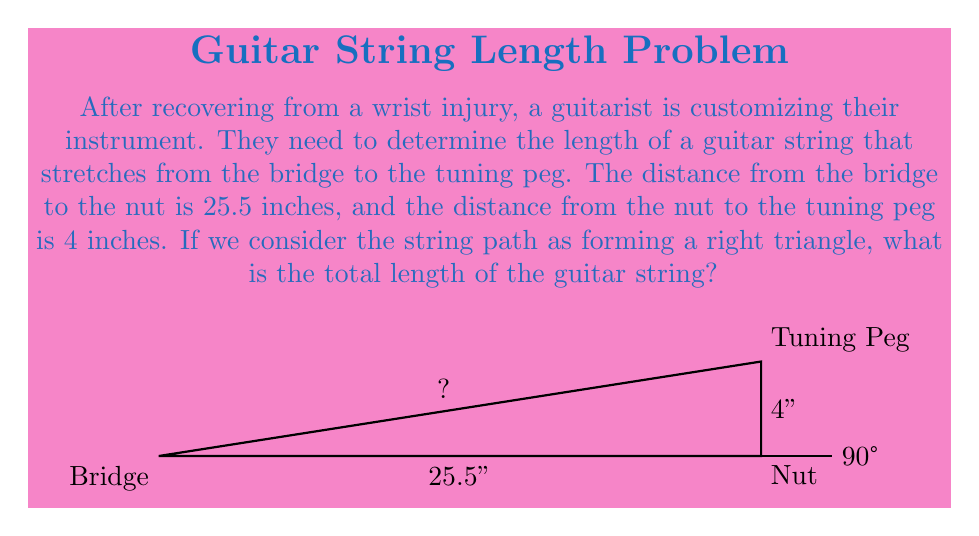Teach me how to tackle this problem. To solve this problem, we can use the Pythagorean theorem, which states that in a right triangle, the square of the length of the hypotenuse is equal to the sum of the squares of the other two sides.

Let's break it down step-by-step:

1) Let's denote the length of the string (hypotenuse) as $c$.

2) We know:
   - The distance from bridge to nut (base) is 25.5 inches
   - The distance from nut to tuning peg (height) is 4 inches

3) Using the Pythagorean theorem:

   $$c^2 = 25.5^2 + 4^2$$

4) Let's calculate the right side:
   $$c^2 = 650.25 + 16 = 666.25$$

5) To find $c$, we need to take the square root of both sides:
   $$c = \sqrt{666.25}$$

6) Using a calculator or simplifying:
   $$c \approx 25.81 \text{ inches}$$

Therefore, the total length of the guitar string is approximately 25.81 inches.
Answer: $25.81 \text{ inches}$ 